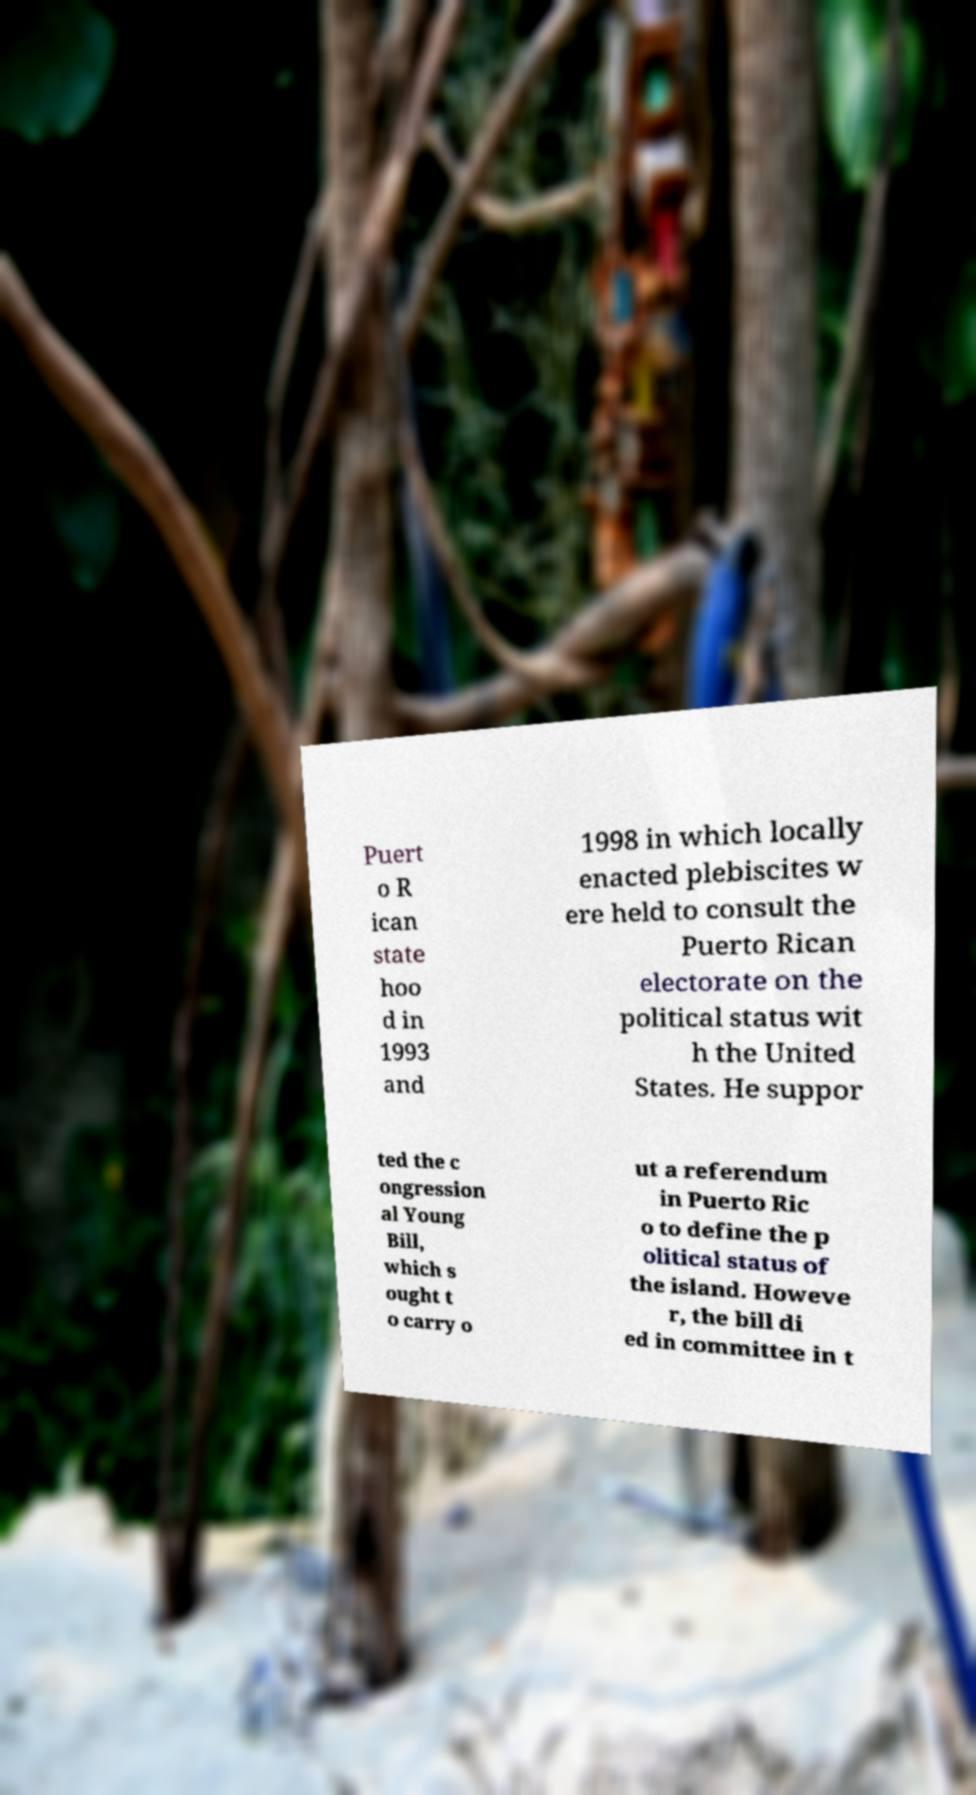Could you assist in decoding the text presented in this image and type it out clearly? Puert o R ican state hoo d in 1993 and 1998 in which locally enacted plebiscites w ere held to consult the Puerto Rican electorate on the political status wit h the United States. He suppor ted the c ongression al Young Bill, which s ought t o carry o ut a referendum in Puerto Ric o to define the p olitical status of the island. Howeve r, the bill di ed in committee in t 